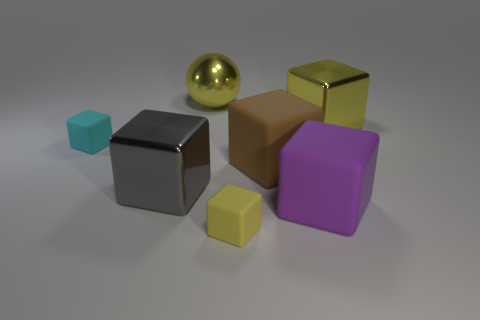Are there an equal number of yellow cubes that are left of the tiny cyan matte block and large yellow balls right of the large yellow metal ball? After examining the image, it appears that there is only one yellow cube located to the left of the tiny cyan matte block and one large yellow ball positioned to the right of the large yellow metal ball. Thus, affirming that there is indeed an equal number of them as per your inquiry. 